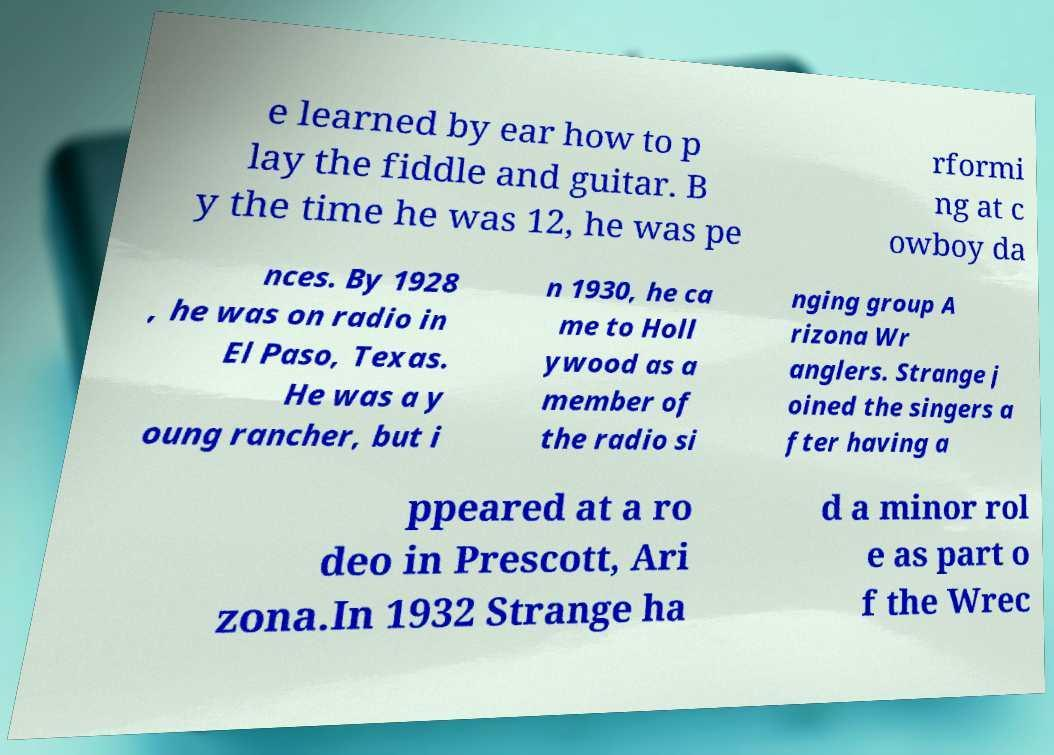There's text embedded in this image that I need extracted. Can you transcribe it verbatim? e learned by ear how to p lay the fiddle and guitar. B y the time he was 12, he was pe rformi ng at c owboy da nces. By 1928 , he was on radio in El Paso, Texas. He was a y oung rancher, but i n 1930, he ca me to Holl ywood as a member of the radio si nging group A rizona Wr anglers. Strange j oined the singers a fter having a ppeared at a ro deo in Prescott, Ari zona.In 1932 Strange ha d a minor rol e as part o f the Wrec 